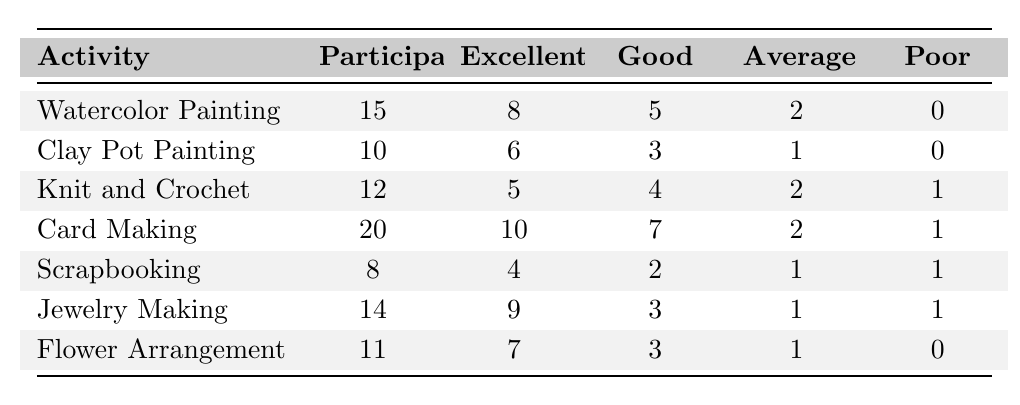What is the total number of participants in all activities combined? To find the total number of participants, we sum the participant counts for each activity: 15 (Watercolor Painting) + 10 (Clay Pot Painting) + 12 (Knit and Crochet) + 20 (Card Making) + 8 (Scrapbooking) + 14 (Jewelry Making) + 11 (Flower Arrangement) = 100.
Answer: 100 Which craft activity received the highest number of "excellent" feedback ratings? By comparing the "excellent" feedback ratings across all activities, we see that Card Making received 10 ratings, which is the highest.
Answer: Card Making What percentage of participants in the Knit and Crochet activity rated it as "poor"? The Knit and Crochet activity has 12 participants, and 1 of them rated it as "poor." To find the percentage, we divide 1 by 12 and multiply by 100: (1/12) * 100 = 8.33%.
Answer: 8.33% How many more "excellent" ratings did Watercolor Painting receive compared to Scrapbooking? Watercolor Painting received 8 "excellent" ratings, while Scrapbooking received 4. The difference is 8 - 4 = 4.
Answer: 4 What is the average number of "good" ratings across all activities? Summing the "good" ratings: 5 (Watercolor Painting) + 3 (Clay Pot Painting) + 4 (Knit and Crochet) + 7 (Card Making) + 2 (Scrapbooking) + 3 (Jewelry Making) + 3 (Flower Arrangement) = 27. There are 7 activities, so the average is 27 / 7 = 3.857, which rounds to approximately 3.86.
Answer: 3.86 Did any activity receive no "poor" ratings? Reviewing the table, Clay Pot Painting, Watercolor Painting, and Flower Arrangement each received 0 "poor" ratings. Therefore, the answer is yes.
Answer: Yes Which activity has the lowest total feedback (sum of all ratings)? The activity feedbacks are: Watercolor Painting (15), Clay Pot Painting (10), Knit and Crochet (12), Card Making (20), Scrapbooking (8), Jewelry Making (14), Flower Arrangement (11). The total feedback for Scrapbooking is 8 participants, which is the lowest.
Answer: Scrapbooking What is the ratio of "excellent" ratings to "poor" ratings for Jewelry Making? Jewelry Making received 9 "excellent" ratings and 1 "poor" rating. The ratio is 9:1.
Answer: 9:1 How many total ratings did participants give to the Card Making activity? Card Making received 10 "excellent," 7 "good," 2 "average," and 1 "poor" ratings. To find the total, we add these: 10 + 7 + 2 + 1 = 20.
Answer: 20 